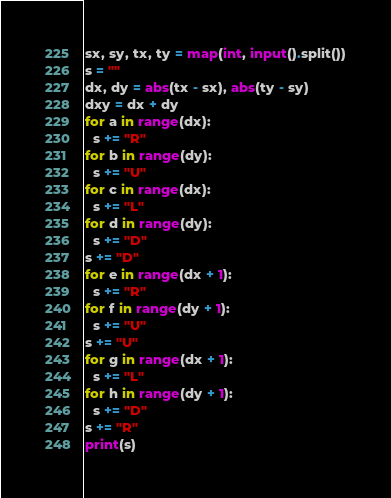Convert code to text. <code><loc_0><loc_0><loc_500><loc_500><_Python_>sx, sy, tx, ty = map(int, input().split())
s = ""
dx, dy = abs(tx - sx), abs(ty - sy)
dxy = dx + dy
for a in range(dx):
  s += "R"
for b in range(dy):
  s += "U"
for c in range(dx):
  s += "L"
for d in range(dy):
  s += "D"
s += "D"
for e in range(dx + 1):
  s += "R"
for f in range(dy + 1):
  s += "U"
s += "U"
for g in range(dx + 1):
  s += "L"
for h in range(dy + 1):
  s += "D"
s += "R"
print(s)</code> 